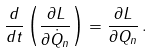Convert formula to latex. <formula><loc_0><loc_0><loc_500><loc_500>\frac { d } { d t } \left ( \frac { \partial L } { \partial \dot { Q } _ { n } } \right ) = \frac { \partial L } { \partial Q _ { n } } \, .</formula> 